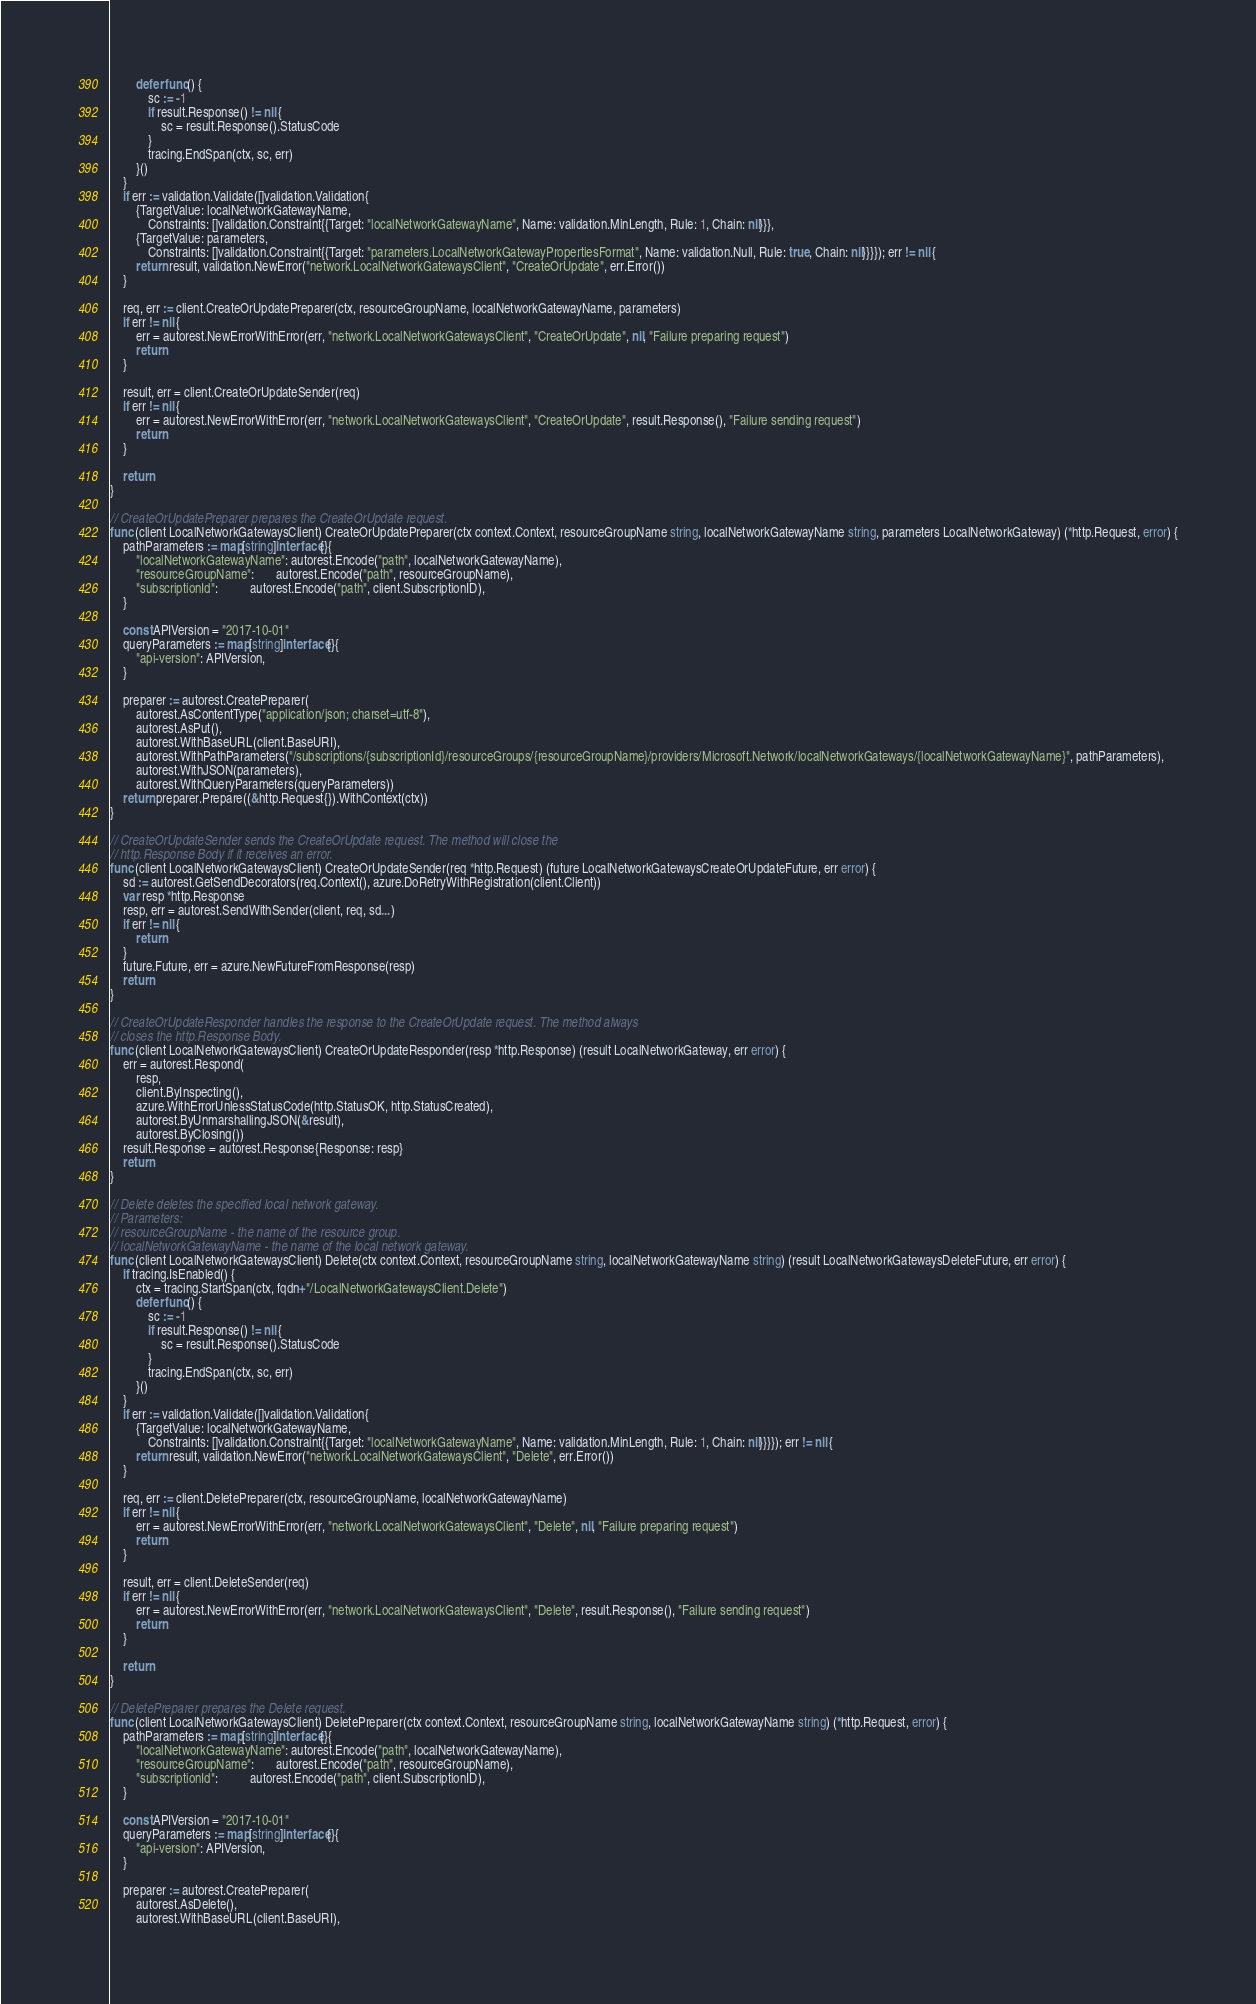Convert code to text. <code><loc_0><loc_0><loc_500><loc_500><_Go_>		defer func() {
			sc := -1
			if result.Response() != nil {
				sc = result.Response().StatusCode
			}
			tracing.EndSpan(ctx, sc, err)
		}()
	}
	if err := validation.Validate([]validation.Validation{
		{TargetValue: localNetworkGatewayName,
			Constraints: []validation.Constraint{{Target: "localNetworkGatewayName", Name: validation.MinLength, Rule: 1, Chain: nil}}},
		{TargetValue: parameters,
			Constraints: []validation.Constraint{{Target: "parameters.LocalNetworkGatewayPropertiesFormat", Name: validation.Null, Rule: true, Chain: nil}}}}); err != nil {
		return result, validation.NewError("network.LocalNetworkGatewaysClient", "CreateOrUpdate", err.Error())
	}

	req, err := client.CreateOrUpdatePreparer(ctx, resourceGroupName, localNetworkGatewayName, parameters)
	if err != nil {
		err = autorest.NewErrorWithError(err, "network.LocalNetworkGatewaysClient", "CreateOrUpdate", nil, "Failure preparing request")
		return
	}

	result, err = client.CreateOrUpdateSender(req)
	if err != nil {
		err = autorest.NewErrorWithError(err, "network.LocalNetworkGatewaysClient", "CreateOrUpdate", result.Response(), "Failure sending request")
		return
	}

	return
}

// CreateOrUpdatePreparer prepares the CreateOrUpdate request.
func (client LocalNetworkGatewaysClient) CreateOrUpdatePreparer(ctx context.Context, resourceGroupName string, localNetworkGatewayName string, parameters LocalNetworkGateway) (*http.Request, error) {
	pathParameters := map[string]interface{}{
		"localNetworkGatewayName": autorest.Encode("path", localNetworkGatewayName),
		"resourceGroupName":       autorest.Encode("path", resourceGroupName),
		"subscriptionId":          autorest.Encode("path", client.SubscriptionID),
	}

	const APIVersion = "2017-10-01"
	queryParameters := map[string]interface{}{
		"api-version": APIVersion,
	}

	preparer := autorest.CreatePreparer(
		autorest.AsContentType("application/json; charset=utf-8"),
		autorest.AsPut(),
		autorest.WithBaseURL(client.BaseURI),
		autorest.WithPathParameters("/subscriptions/{subscriptionId}/resourceGroups/{resourceGroupName}/providers/Microsoft.Network/localNetworkGateways/{localNetworkGatewayName}", pathParameters),
		autorest.WithJSON(parameters),
		autorest.WithQueryParameters(queryParameters))
	return preparer.Prepare((&http.Request{}).WithContext(ctx))
}

// CreateOrUpdateSender sends the CreateOrUpdate request. The method will close the
// http.Response Body if it receives an error.
func (client LocalNetworkGatewaysClient) CreateOrUpdateSender(req *http.Request) (future LocalNetworkGatewaysCreateOrUpdateFuture, err error) {
	sd := autorest.GetSendDecorators(req.Context(), azure.DoRetryWithRegistration(client.Client))
	var resp *http.Response
	resp, err = autorest.SendWithSender(client, req, sd...)
	if err != nil {
		return
	}
	future.Future, err = azure.NewFutureFromResponse(resp)
	return
}

// CreateOrUpdateResponder handles the response to the CreateOrUpdate request. The method always
// closes the http.Response Body.
func (client LocalNetworkGatewaysClient) CreateOrUpdateResponder(resp *http.Response) (result LocalNetworkGateway, err error) {
	err = autorest.Respond(
		resp,
		client.ByInspecting(),
		azure.WithErrorUnlessStatusCode(http.StatusOK, http.StatusCreated),
		autorest.ByUnmarshallingJSON(&result),
		autorest.ByClosing())
	result.Response = autorest.Response{Response: resp}
	return
}

// Delete deletes the specified local network gateway.
// Parameters:
// resourceGroupName - the name of the resource group.
// localNetworkGatewayName - the name of the local network gateway.
func (client LocalNetworkGatewaysClient) Delete(ctx context.Context, resourceGroupName string, localNetworkGatewayName string) (result LocalNetworkGatewaysDeleteFuture, err error) {
	if tracing.IsEnabled() {
		ctx = tracing.StartSpan(ctx, fqdn+"/LocalNetworkGatewaysClient.Delete")
		defer func() {
			sc := -1
			if result.Response() != nil {
				sc = result.Response().StatusCode
			}
			tracing.EndSpan(ctx, sc, err)
		}()
	}
	if err := validation.Validate([]validation.Validation{
		{TargetValue: localNetworkGatewayName,
			Constraints: []validation.Constraint{{Target: "localNetworkGatewayName", Name: validation.MinLength, Rule: 1, Chain: nil}}}}); err != nil {
		return result, validation.NewError("network.LocalNetworkGatewaysClient", "Delete", err.Error())
	}

	req, err := client.DeletePreparer(ctx, resourceGroupName, localNetworkGatewayName)
	if err != nil {
		err = autorest.NewErrorWithError(err, "network.LocalNetworkGatewaysClient", "Delete", nil, "Failure preparing request")
		return
	}

	result, err = client.DeleteSender(req)
	if err != nil {
		err = autorest.NewErrorWithError(err, "network.LocalNetworkGatewaysClient", "Delete", result.Response(), "Failure sending request")
		return
	}

	return
}

// DeletePreparer prepares the Delete request.
func (client LocalNetworkGatewaysClient) DeletePreparer(ctx context.Context, resourceGroupName string, localNetworkGatewayName string) (*http.Request, error) {
	pathParameters := map[string]interface{}{
		"localNetworkGatewayName": autorest.Encode("path", localNetworkGatewayName),
		"resourceGroupName":       autorest.Encode("path", resourceGroupName),
		"subscriptionId":          autorest.Encode("path", client.SubscriptionID),
	}

	const APIVersion = "2017-10-01"
	queryParameters := map[string]interface{}{
		"api-version": APIVersion,
	}

	preparer := autorest.CreatePreparer(
		autorest.AsDelete(),
		autorest.WithBaseURL(client.BaseURI),</code> 